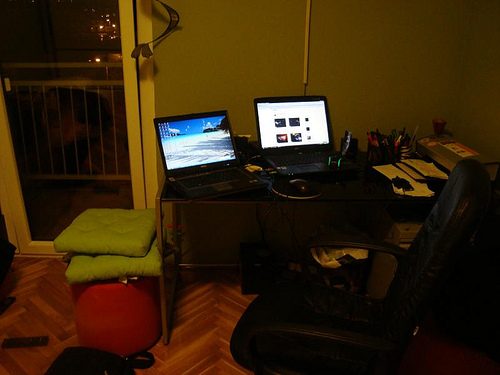<image>What is on the cart? It is unknown what is on the cart. It can be seen as cushions, computers or towels. What is on the cart? I am not sure what is on the cart. It can be seen cushions, laptop, computers, computer or towels. 